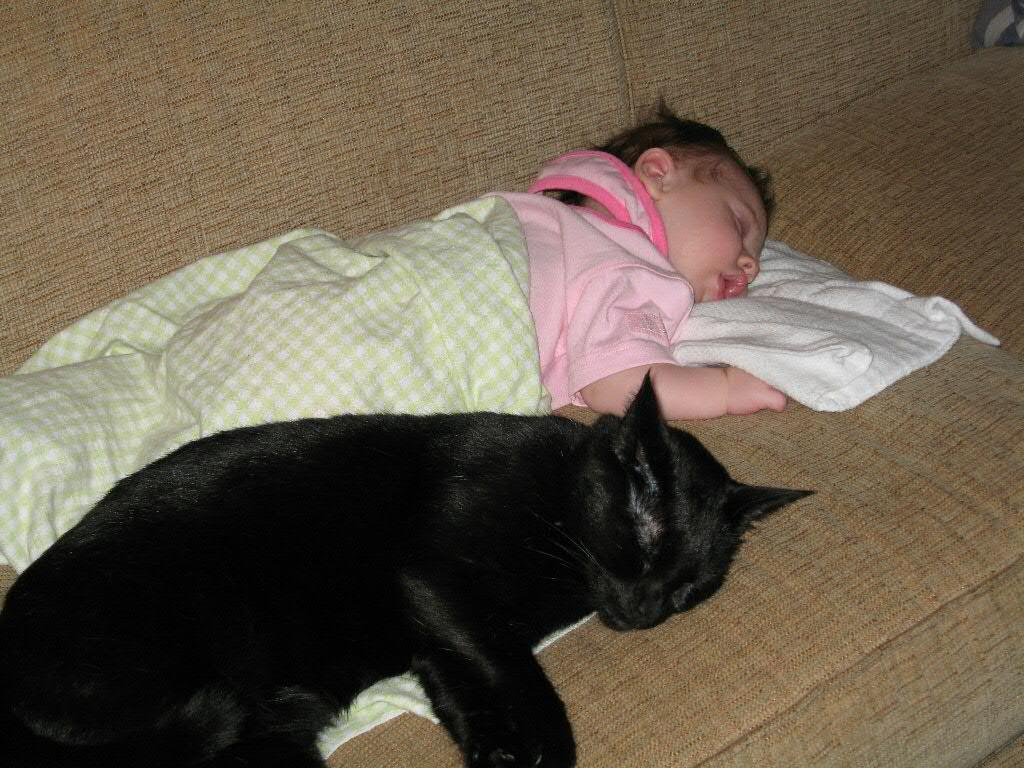What is the main subject of the image? The main subject of the image is a kid. What is the kid doing in the image? The kid is lying on a couch. Is there any other living creature in the image? Yes, there is a cat in the image. What is the cat doing in the image? The cat is also lying on the couch. What else can be seen in the image? Clothes are visible in the image. Can you tell me how many hens are present in the image? There are no hens present in the image. What type of glue is being used to hold the cat and kid together in the image? There is no glue present in the image, and the cat and kid are not physically connected. 